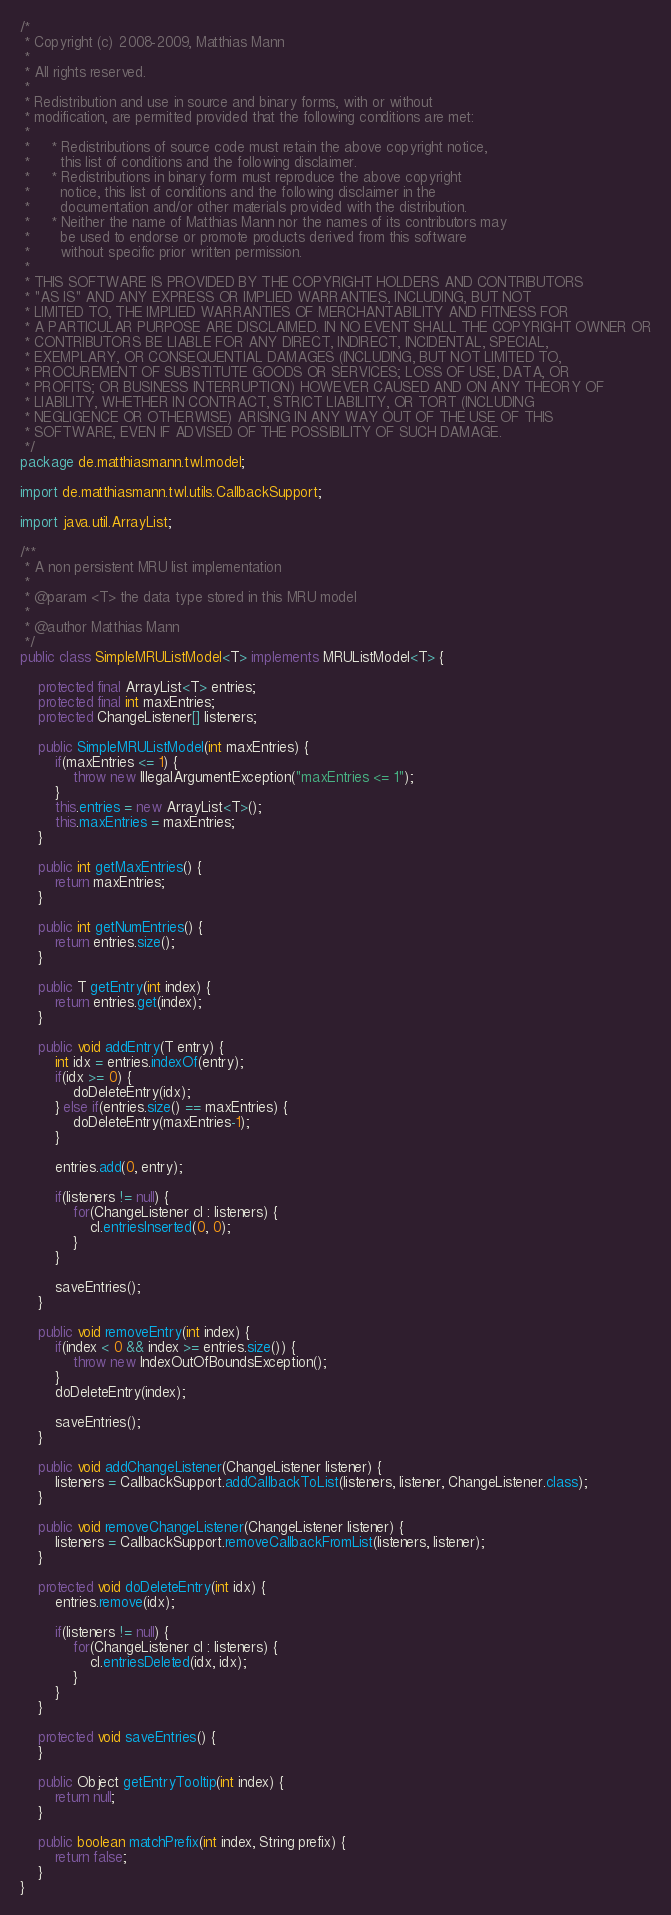<code> <loc_0><loc_0><loc_500><loc_500><_Java_>/*
 * Copyright (c) 2008-2009, Matthias Mann
 *
 * All rights reserved.
 *
 * Redistribution and use in source and binary forms, with or without
 * modification, are permitted provided that the following conditions are met:
 *
 *     * Redistributions of source code must retain the above copyright notice,
 *       this list of conditions and the following disclaimer.
 *     * Redistributions in binary form must reproduce the above copyright
 *       notice, this list of conditions and the following disclaimer in the
 *       documentation and/or other materials provided with the distribution.
 *     * Neither the name of Matthias Mann nor the names of its contributors may
 *       be used to endorse or promote products derived from this software
 *       without specific prior written permission.
 *
 * THIS SOFTWARE IS PROVIDED BY THE COPYRIGHT HOLDERS AND CONTRIBUTORS
 * "AS IS" AND ANY EXPRESS OR IMPLIED WARRANTIES, INCLUDING, BUT NOT
 * LIMITED TO, THE IMPLIED WARRANTIES OF MERCHANTABILITY AND FITNESS FOR
 * A PARTICULAR PURPOSE ARE DISCLAIMED. IN NO EVENT SHALL THE COPYRIGHT OWNER OR
 * CONTRIBUTORS BE LIABLE FOR ANY DIRECT, INDIRECT, INCIDENTAL, SPECIAL,
 * EXEMPLARY, OR CONSEQUENTIAL DAMAGES (INCLUDING, BUT NOT LIMITED TO,
 * PROCUREMENT OF SUBSTITUTE GOODS OR SERVICES; LOSS OF USE, DATA, OR
 * PROFITS; OR BUSINESS INTERRUPTION) HOWEVER CAUSED AND ON ANY THEORY OF
 * LIABILITY, WHETHER IN CONTRACT, STRICT LIABILITY, OR TORT (INCLUDING
 * NEGLIGENCE OR OTHERWISE) ARISING IN ANY WAY OUT OF THE USE OF THIS
 * SOFTWARE, EVEN IF ADVISED OF THE POSSIBILITY OF SUCH DAMAGE.
 */
package de.matthiasmann.twl.model;

import de.matthiasmann.twl.utils.CallbackSupport;

import java.util.ArrayList;

/**
 * A non persistent MRU list implementation
 *
 * @param <T> the data type stored in this MRU model
 * 
 * @author Matthias Mann
 */
public class SimpleMRUListModel<T> implements MRUListModel<T> {

    protected final ArrayList<T> entries;
    protected final int maxEntries;
    protected ChangeListener[] listeners;

    public SimpleMRUListModel(int maxEntries) {
        if(maxEntries <= 1) {
            throw new IllegalArgumentException("maxEntries <= 1");
        }
        this.entries = new ArrayList<T>();
        this.maxEntries = maxEntries;
    }

    public int getMaxEntries() {
        return maxEntries;
    }

    public int getNumEntries() {
        return entries.size();
    }

    public T getEntry(int index) {
        return entries.get(index);
    }

    public void addEntry(T entry) {
        int idx = entries.indexOf(entry);
        if(idx >= 0) {
            doDeleteEntry(idx);
        } else if(entries.size() == maxEntries) {
            doDeleteEntry(maxEntries-1);
        }
        
        entries.add(0, entry);

        if(listeners != null) {
            for(ChangeListener cl : listeners) {
                cl.entriesInserted(0, 0);
            }
        }

        saveEntries();
    }

    public void removeEntry(int index) {
        if(index < 0 && index >= entries.size()) {
            throw new IndexOutOfBoundsException();
        }
        doDeleteEntry(index);
        
        saveEntries();
    }

    public void addChangeListener(ChangeListener listener) {
        listeners = CallbackSupport.addCallbackToList(listeners, listener, ChangeListener.class);
    }

    public void removeChangeListener(ChangeListener listener) {
        listeners = CallbackSupport.removeCallbackFromList(listeners, listener);
    }

    protected void doDeleteEntry(int idx) {
        entries.remove(idx);
        
        if(listeners != null) {
            for(ChangeListener cl : listeners) {
                cl.entriesDeleted(idx, idx);
            }
        }
    }

    protected void saveEntries() {
    }

    public Object getEntryTooltip(int index) {
        return null;
    }

    public boolean matchPrefix(int index, String prefix) {
        return false;
    }
}
</code> 